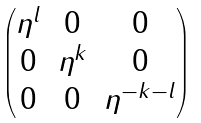Convert formula to latex. <formula><loc_0><loc_0><loc_500><loc_500>\begin{pmatrix} \eta ^ { l } & 0 & 0 \\ 0 & \eta ^ { k } & 0 \\ 0 & 0 & \eta ^ { - k - l } \end{pmatrix}</formula> 